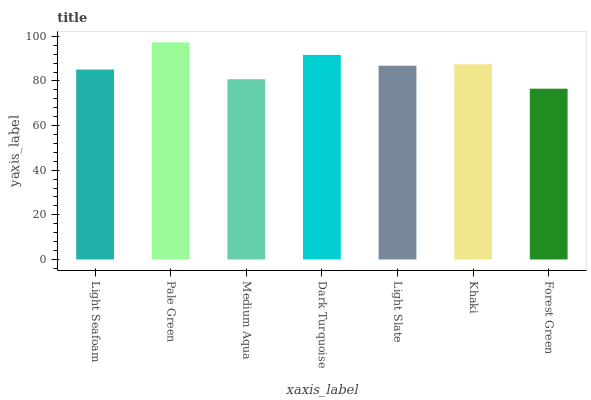Is Forest Green the minimum?
Answer yes or no. Yes. Is Pale Green the maximum?
Answer yes or no. Yes. Is Medium Aqua the minimum?
Answer yes or no. No. Is Medium Aqua the maximum?
Answer yes or no. No. Is Pale Green greater than Medium Aqua?
Answer yes or no. Yes. Is Medium Aqua less than Pale Green?
Answer yes or no. Yes. Is Medium Aqua greater than Pale Green?
Answer yes or no. No. Is Pale Green less than Medium Aqua?
Answer yes or no. No. Is Light Slate the high median?
Answer yes or no. Yes. Is Light Slate the low median?
Answer yes or no. Yes. Is Khaki the high median?
Answer yes or no. No. Is Light Seafoam the low median?
Answer yes or no. No. 